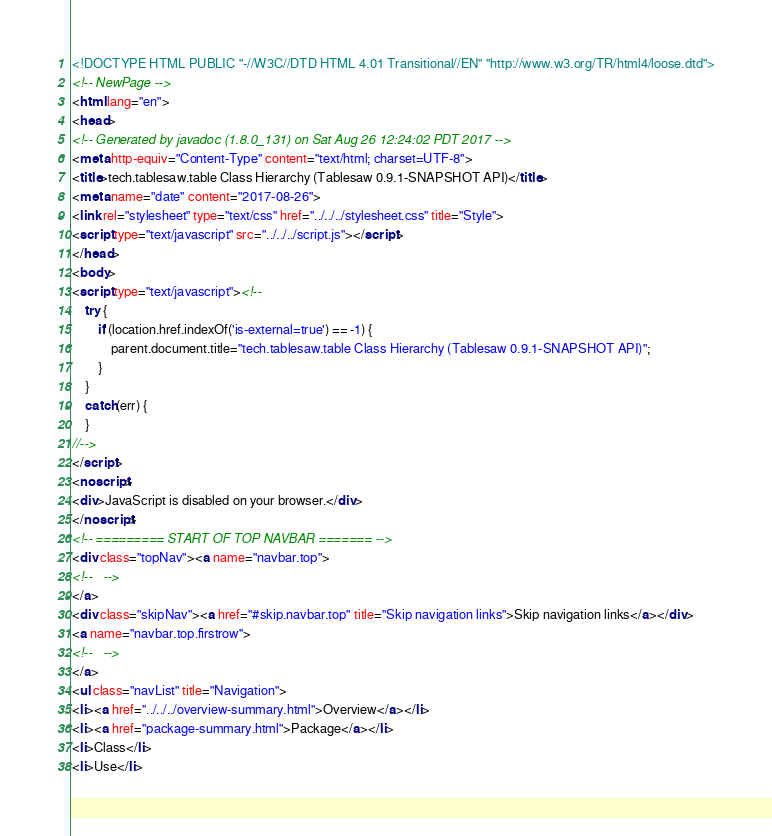<code> <loc_0><loc_0><loc_500><loc_500><_HTML_><!DOCTYPE HTML PUBLIC "-//W3C//DTD HTML 4.01 Transitional//EN" "http://www.w3.org/TR/html4/loose.dtd">
<!-- NewPage -->
<html lang="en">
<head>
<!-- Generated by javadoc (1.8.0_131) on Sat Aug 26 12:24:02 PDT 2017 -->
<meta http-equiv="Content-Type" content="text/html; charset=UTF-8">
<title>tech.tablesaw.table Class Hierarchy (Tablesaw 0.9.1-SNAPSHOT API)</title>
<meta name="date" content="2017-08-26">
<link rel="stylesheet" type="text/css" href="../../../stylesheet.css" title="Style">
<script type="text/javascript" src="../../../script.js"></script>
</head>
<body>
<script type="text/javascript"><!--
    try {
        if (location.href.indexOf('is-external=true') == -1) {
            parent.document.title="tech.tablesaw.table Class Hierarchy (Tablesaw 0.9.1-SNAPSHOT API)";
        }
    }
    catch(err) {
    }
//-->
</script>
<noscript>
<div>JavaScript is disabled on your browser.</div>
</noscript>
<!-- ========= START OF TOP NAVBAR ======= -->
<div class="topNav"><a name="navbar.top">
<!--   -->
</a>
<div class="skipNav"><a href="#skip.navbar.top" title="Skip navigation links">Skip navigation links</a></div>
<a name="navbar.top.firstrow">
<!--   -->
</a>
<ul class="navList" title="Navigation">
<li><a href="../../../overview-summary.html">Overview</a></li>
<li><a href="package-summary.html">Package</a></li>
<li>Class</li>
<li>Use</li></code> 